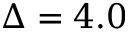<formula> <loc_0><loc_0><loc_500><loc_500>\Delta = 4 . 0</formula> 